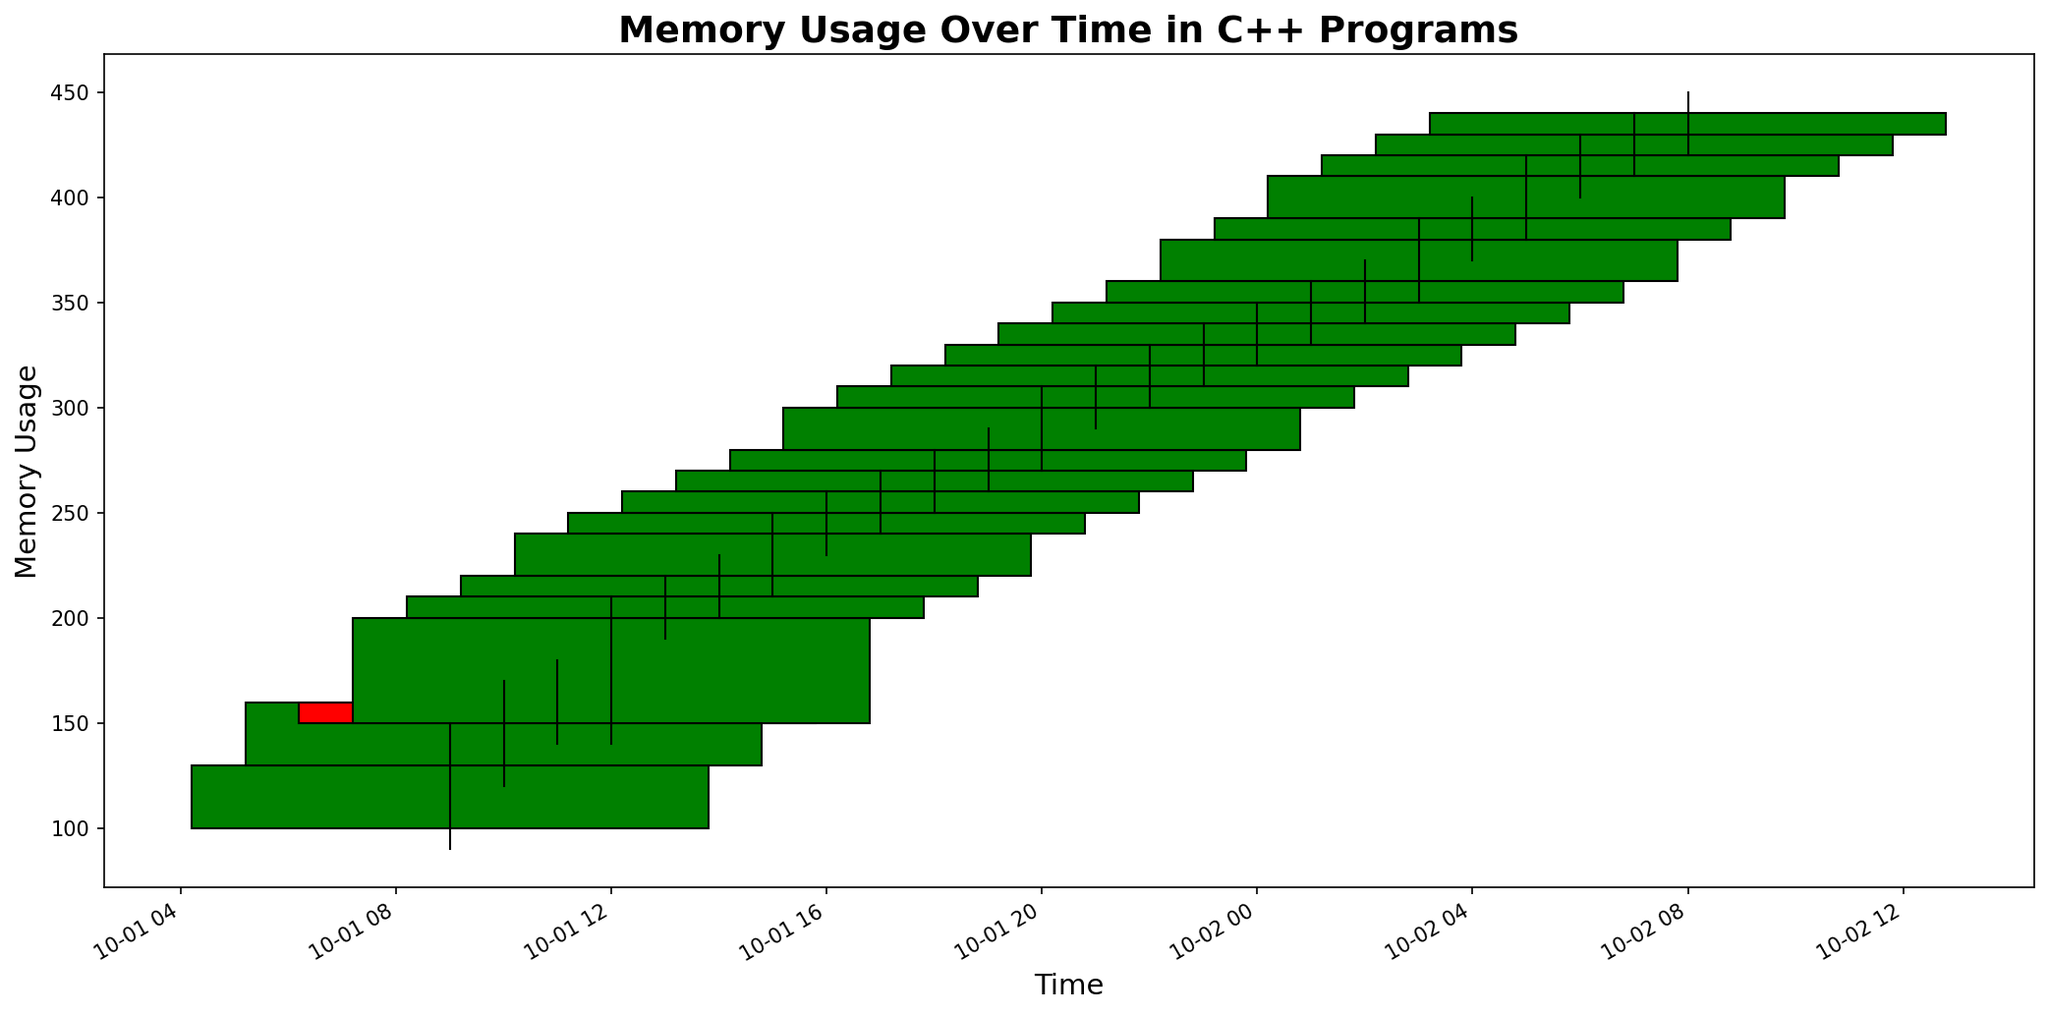What was the highest memory usage observed during the period? The highest memory usage is the maximum value in the 'High' column. From the data, it occurred at 2023-10-02 05:00 with a value of 420.
Answer: 420 What time did the memory usage close at the highest value? To answer this, we need to find the 'Close' value that is the highest. The highest 'Close' value is 440, which occurred on 2023-10-02 08:00.
Answer: 2023-10-02 08:00 During which hour did the memory usage show the largest increase within the hour? To determine this, calculate the difference between 'Close' and 'Open' for each period. The largest increase is 60 occurring from 2023-10-01 12:00 to 13:00 (200 - 150).
Answer: 2023-10-01 12:00 to 13:00 What is the total range of memory usage values observed on 2023-10-02? The total range is calculated by taking the highest 'High' value and subtracting the lowest 'Low' value on 2023-10-02. The highest is 430 and the lowest is 320. Therefore, the range is 430 - 320 = 110.
Answer: 110 Which time period had no change in memory usage by the end of the hour? No change means the 'Open' and 'Close' values are the same. From the data, no time period has an 'Open' equal to 'Close'. Therefore, there is no such period.
Answer: None At which hour did the memory allocation reach its minimum 'Low' value on 2023-10-01? The minimum 'Low' value for 2023-10-01 is 90, and it occurred at 09:00.
Answer: 09:00 Was there always an increase in memory usage from one hour to the next? To determine this, check if each 'Close' value is higher than the previous 'Close' value. Not all periods show an increase; for example, from 2023-10-01 10:00 to 11:00, the 'Close' value decreased from 160 to 150.
Answer: No During which hour span did the memory usage show the highest volatility? Volatility can be represented by the difference between 'High' and 'Low' values within an hour. The largest difference is (420 - 380) = 40 on 2023-10-02 05:00.
Answer: 2023-10-02 05:00 Compare the first and last recorded memory usage values. Has it increased or decreased by the end? The first recorded 'Open' value is 100 and the last recorded 'Close' value is 440. Comparing 440 to 100 shows an overall increase.
Answer: Increased What was the trend of the closing memory values in the evening of October 1st? To determine the trend on the evening of October 1st, we look at the 'Close' values from 18:00 to 23:00, which are 270, 280, 310, 320, 330. The values are consistently increasing.
Answer: Increasing 